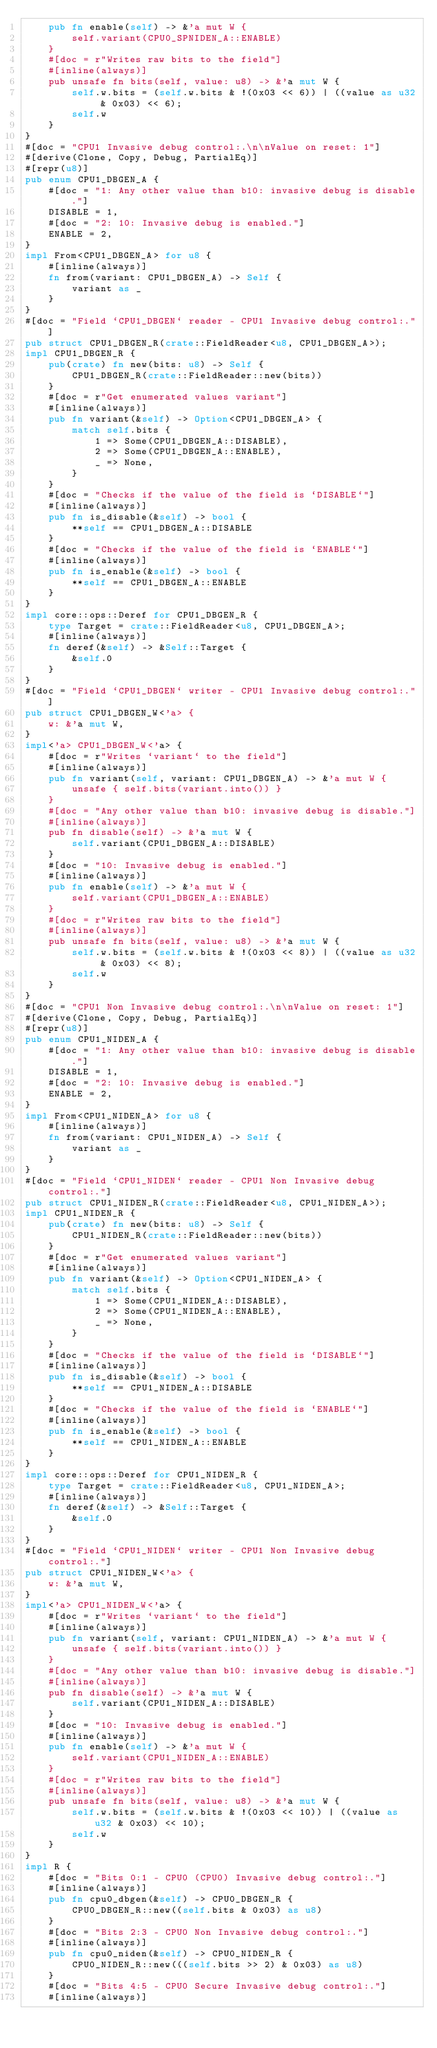<code> <loc_0><loc_0><loc_500><loc_500><_Rust_>    pub fn enable(self) -> &'a mut W {
        self.variant(CPU0_SPNIDEN_A::ENABLE)
    }
    #[doc = r"Writes raw bits to the field"]
    #[inline(always)]
    pub unsafe fn bits(self, value: u8) -> &'a mut W {
        self.w.bits = (self.w.bits & !(0x03 << 6)) | ((value as u32 & 0x03) << 6);
        self.w
    }
}
#[doc = "CPU1 Invasive debug control:.\n\nValue on reset: 1"]
#[derive(Clone, Copy, Debug, PartialEq)]
#[repr(u8)]
pub enum CPU1_DBGEN_A {
    #[doc = "1: Any other value than b10: invasive debug is disable."]
    DISABLE = 1,
    #[doc = "2: 10: Invasive debug is enabled."]
    ENABLE = 2,
}
impl From<CPU1_DBGEN_A> for u8 {
    #[inline(always)]
    fn from(variant: CPU1_DBGEN_A) -> Self {
        variant as _
    }
}
#[doc = "Field `CPU1_DBGEN` reader - CPU1 Invasive debug control:."]
pub struct CPU1_DBGEN_R(crate::FieldReader<u8, CPU1_DBGEN_A>);
impl CPU1_DBGEN_R {
    pub(crate) fn new(bits: u8) -> Self {
        CPU1_DBGEN_R(crate::FieldReader::new(bits))
    }
    #[doc = r"Get enumerated values variant"]
    #[inline(always)]
    pub fn variant(&self) -> Option<CPU1_DBGEN_A> {
        match self.bits {
            1 => Some(CPU1_DBGEN_A::DISABLE),
            2 => Some(CPU1_DBGEN_A::ENABLE),
            _ => None,
        }
    }
    #[doc = "Checks if the value of the field is `DISABLE`"]
    #[inline(always)]
    pub fn is_disable(&self) -> bool {
        **self == CPU1_DBGEN_A::DISABLE
    }
    #[doc = "Checks if the value of the field is `ENABLE`"]
    #[inline(always)]
    pub fn is_enable(&self) -> bool {
        **self == CPU1_DBGEN_A::ENABLE
    }
}
impl core::ops::Deref for CPU1_DBGEN_R {
    type Target = crate::FieldReader<u8, CPU1_DBGEN_A>;
    #[inline(always)]
    fn deref(&self) -> &Self::Target {
        &self.0
    }
}
#[doc = "Field `CPU1_DBGEN` writer - CPU1 Invasive debug control:."]
pub struct CPU1_DBGEN_W<'a> {
    w: &'a mut W,
}
impl<'a> CPU1_DBGEN_W<'a> {
    #[doc = r"Writes `variant` to the field"]
    #[inline(always)]
    pub fn variant(self, variant: CPU1_DBGEN_A) -> &'a mut W {
        unsafe { self.bits(variant.into()) }
    }
    #[doc = "Any other value than b10: invasive debug is disable."]
    #[inline(always)]
    pub fn disable(self) -> &'a mut W {
        self.variant(CPU1_DBGEN_A::DISABLE)
    }
    #[doc = "10: Invasive debug is enabled."]
    #[inline(always)]
    pub fn enable(self) -> &'a mut W {
        self.variant(CPU1_DBGEN_A::ENABLE)
    }
    #[doc = r"Writes raw bits to the field"]
    #[inline(always)]
    pub unsafe fn bits(self, value: u8) -> &'a mut W {
        self.w.bits = (self.w.bits & !(0x03 << 8)) | ((value as u32 & 0x03) << 8);
        self.w
    }
}
#[doc = "CPU1 Non Invasive debug control:.\n\nValue on reset: 1"]
#[derive(Clone, Copy, Debug, PartialEq)]
#[repr(u8)]
pub enum CPU1_NIDEN_A {
    #[doc = "1: Any other value than b10: invasive debug is disable."]
    DISABLE = 1,
    #[doc = "2: 10: Invasive debug is enabled."]
    ENABLE = 2,
}
impl From<CPU1_NIDEN_A> for u8 {
    #[inline(always)]
    fn from(variant: CPU1_NIDEN_A) -> Self {
        variant as _
    }
}
#[doc = "Field `CPU1_NIDEN` reader - CPU1 Non Invasive debug control:."]
pub struct CPU1_NIDEN_R(crate::FieldReader<u8, CPU1_NIDEN_A>);
impl CPU1_NIDEN_R {
    pub(crate) fn new(bits: u8) -> Self {
        CPU1_NIDEN_R(crate::FieldReader::new(bits))
    }
    #[doc = r"Get enumerated values variant"]
    #[inline(always)]
    pub fn variant(&self) -> Option<CPU1_NIDEN_A> {
        match self.bits {
            1 => Some(CPU1_NIDEN_A::DISABLE),
            2 => Some(CPU1_NIDEN_A::ENABLE),
            _ => None,
        }
    }
    #[doc = "Checks if the value of the field is `DISABLE`"]
    #[inline(always)]
    pub fn is_disable(&self) -> bool {
        **self == CPU1_NIDEN_A::DISABLE
    }
    #[doc = "Checks if the value of the field is `ENABLE`"]
    #[inline(always)]
    pub fn is_enable(&self) -> bool {
        **self == CPU1_NIDEN_A::ENABLE
    }
}
impl core::ops::Deref for CPU1_NIDEN_R {
    type Target = crate::FieldReader<u8, CPU1_NIDEN_A>;
    #[inline(always)]
    fn deref(&self) -> &Self::Target {
        &self.0
    }
}
#[doc = "Field `CPU1_NIDEN` writer - CPU1 Non Invasive debug control:."]
pub struct CPU1_NIDEN_W<'a> {
    w: &'a mut W,
}
impl<'a> CPU1_NIDEN_W<'a> {
    #[doc = r"Writes `variant` to the field"]
    #[inline(always)]
    pub fn variant(self, variant: CPU1_NIDEN_A) -> &'a mut W {
        unsafe { self.bits(variant.into()) }
    }
    #[doc = "Any other value than b10: invasive debug is disable."]
    #[inline(always)]
    pub fn disable(self) -> &'a mut W {
        self.variant(CPU1_NIDEN_A::DISABLE)
    }
    #[doc = "10: Invasive debug is enabled."]
    #[inline(always)]
    pub fn enable(self) -> &'a mut W {
        self.variant(CPU1_NIDEN_A::ENABLE)
    }
    #[doc = r"Writes raw bits to the field"]
    #[inline(always)]
    pub unsafe fn bits(self, value: u8) -> &'a mut W {
        self.w.bits = (self.w.bits & !(0x03 << 10)) | ((value as u32 & 0x03) << 10);
        self.w
    }
}
impl R {
    #[doc = "Bits 0:1 - CPU0 (CPU0) Invasive debug control:."]
    #[inline(always)]
    pub fn cpu0_dbgen(&self) -> CPU0_DBGEN_R {
        CPU0_DBGEN_R::new((self.bits & 0x03) as u8)
    }
    #[doc = "Bits 2:3 - CPU0 Non Invasive debug control:."]
    #[inline(always)]
    pub fn cpu0_niden(&self) -> CPU0_NIDEN_R {
        CPU0_NIDEN_R::new(((self.bits >> 2) & 0x03) as u8)
    }
    #[doc = "Bits 4:5 - CPU0 Secure Invasive debug control:."]
    #[inline(always)]</code> 